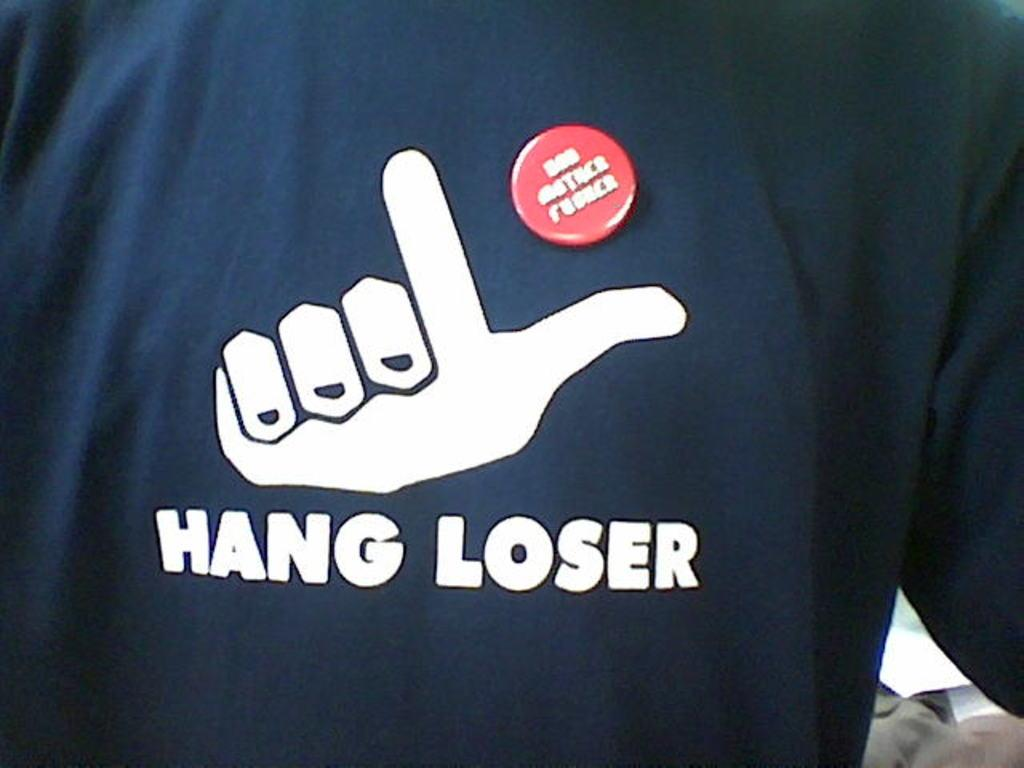Provide a one-sentence caption for the provided image. A shirt with a logo and the words Hang Loser on it. 